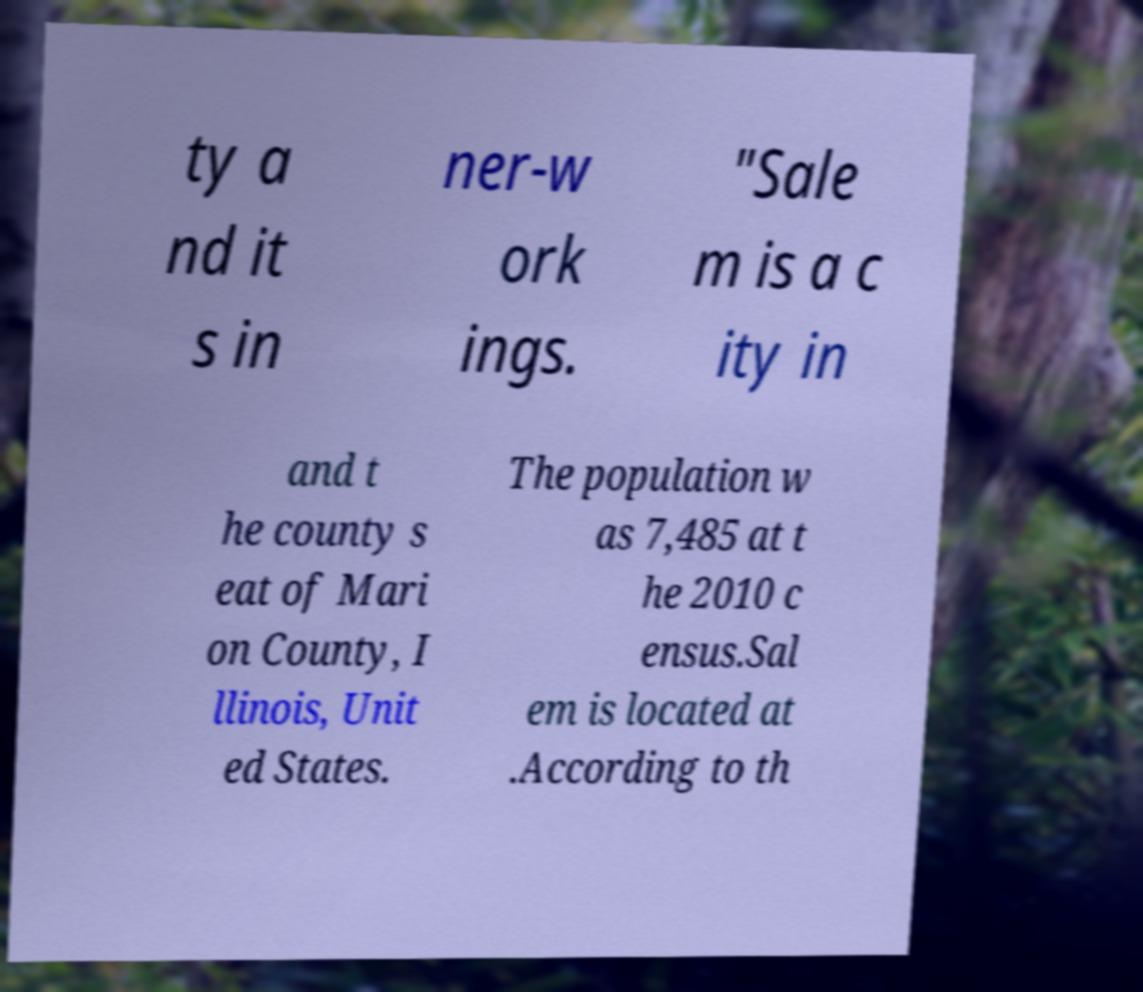There's text embedded in this image that I need extracted. Can you transcribe it verbatim? ty a nd it s in ner-w ork ings. "Sale m is a c ity in and t he county s eat of Mari on County, I llinois, Unit ed States. The population w as 7,485 at t he 2010 c ensus.Sal em is located at .According to th 